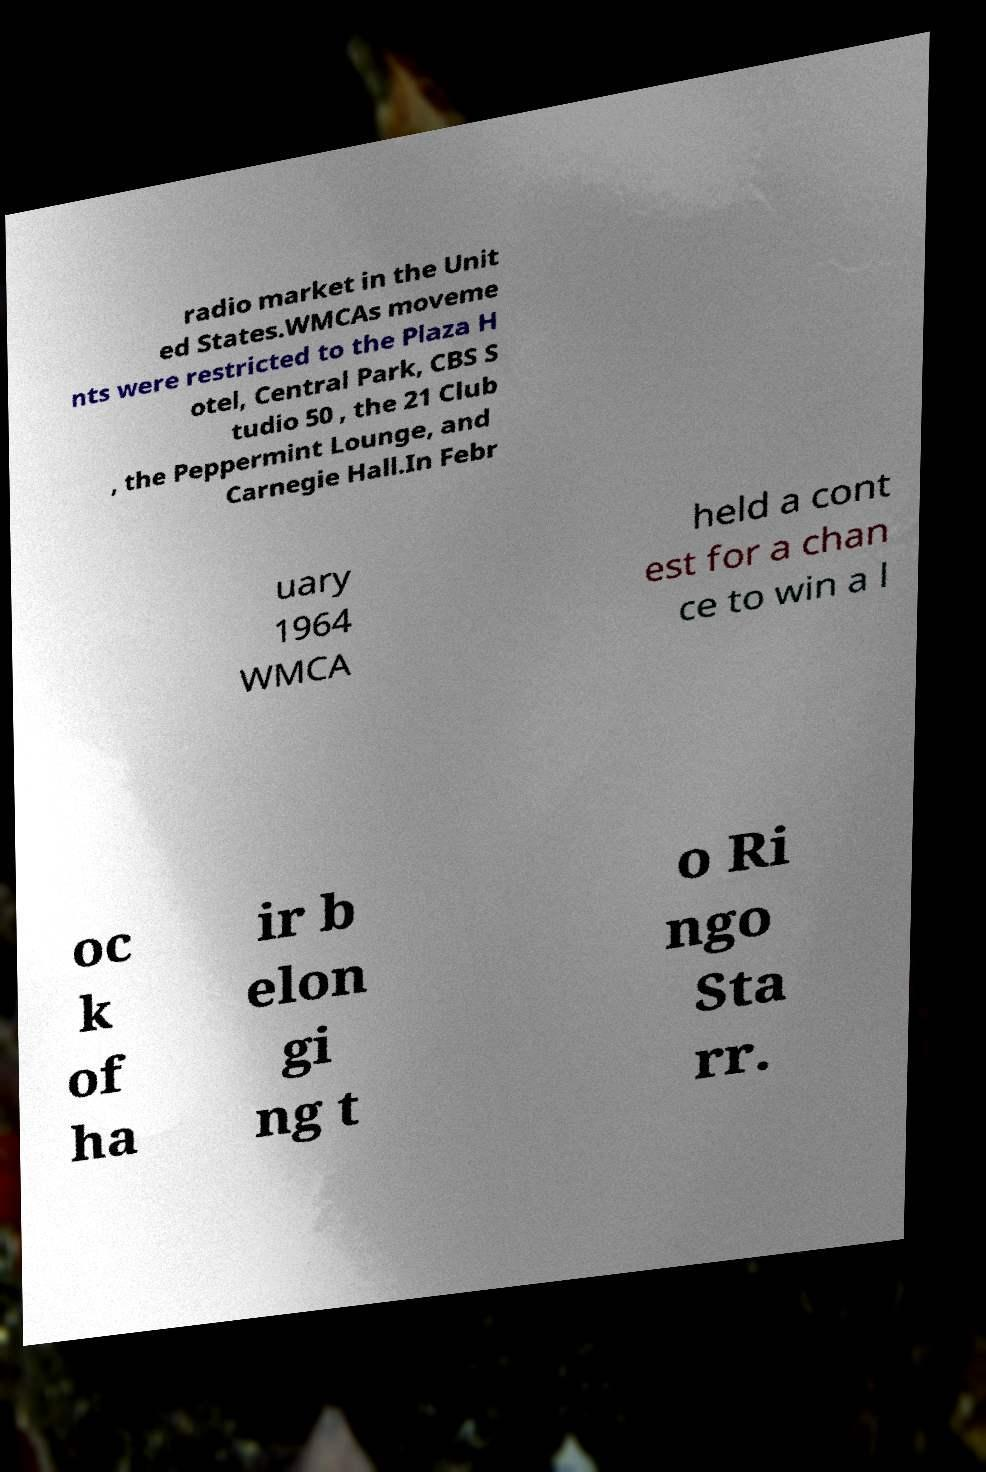For documentation purposes, I need the text within this image transcribed. Could you provide that? radio market in the Unit ed States.WMCAs moveme nts were restricted to the Plaza H otel, Central Park, CBS S tudio 50 , the 21 Club , the Peppermint Lounge, and Carnegie Hall.In Febr uary 1964 WMCA held a cont est for a chan ce to win a l oc k of ha ir b elon gi ng t o Ri ngo Sta rr. 